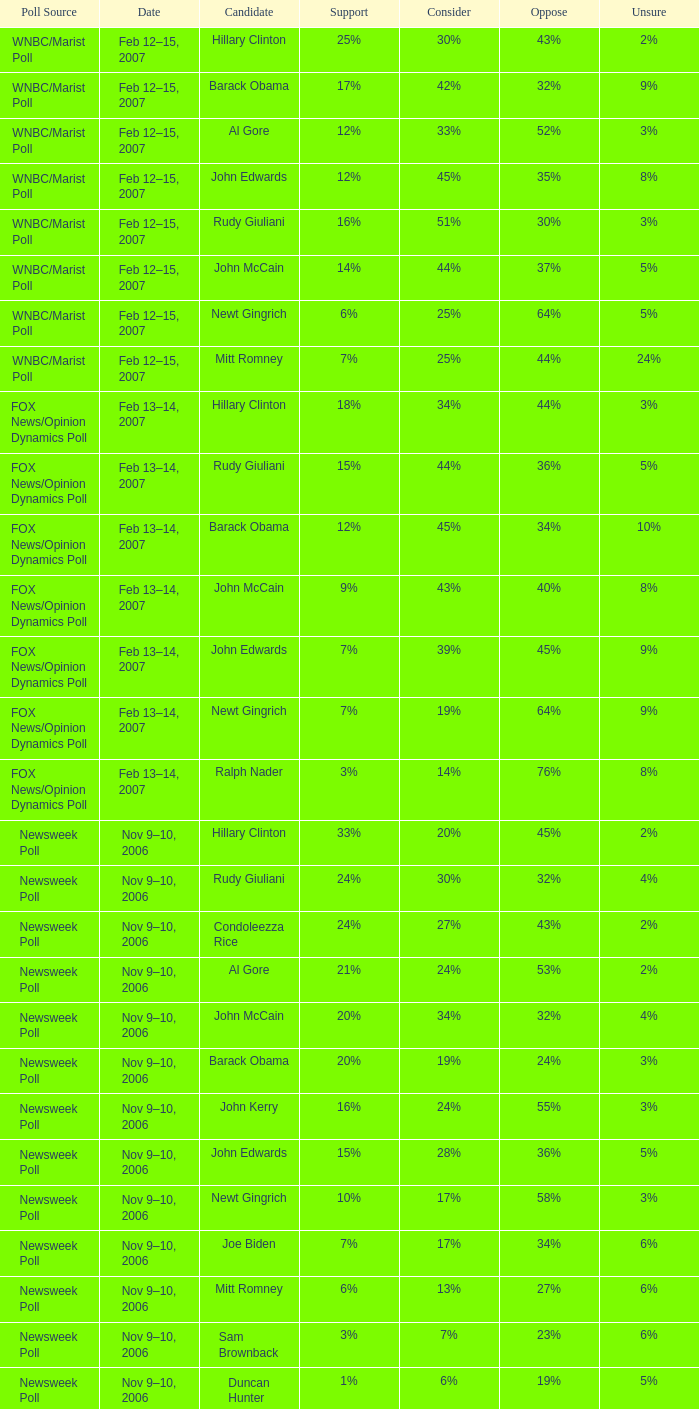In the time poll, which showed 6% of people being unsure, what was the percentage of those who did not support the candidate? 34%. Parse the table in full. {'header': ['Poll Source', 'Date', 'Candidate', 'Support', 'Consider', 'Oppose', 'Unsure'], 'rows': [['WNBC/Marist Poll', 'Feb 12–15, 2007', 'Hillary Clinton', '25%', '30%', '43%', '2%'], ['WNBC/Marist Poll', 'Feb 12–15, 2007', 'Barack Obama', '17%', '42%', '32%', '9%'], ['WNBC/Marist Poll', 'Feb 12–15, 2007', 'Al Gore', '12%', '33%', '52%', '3%'], ['WNBC/Marist Poll', 'Feb 12–15, 2007', 'John Edwards', '12%', '45%', '35%', '8%'], ['WNBC/Marist Poll', 'Feb 12–15, 2007', 'Rudy Giuliani', '16%', '51%', '30%', '3%'], ['WNBC/Marist Poll', 'Feb 12–15, 2007', 'John McCain', '14%', '44%', '37%', '5%'], ['WNBC/Marist Poll', 'Feb 12–15, 2007', 'Newt Gingrich', '6%', '25%', '64%', '5%'], ['WNBC/Marist Poll', 'Feb 12–15, 2007', 'Mitt Romney', '7%', '25%', '44%', '24%'], ['FOX News/Opinion Dynamics Poll', 'Feb 13–14, 2007', 'Hillary Clinton', '18%', '34%', '44%', '3%'], ['FOX News/Opinion Dynamics Poll', 'Feb 13–14, 2007', 'Rudy Giuliani', '15%', '44%', '36%', '5%'], ['FOX News/Opinion Dynamics Poll', 'Feb 13–14, 2007', 'Barack Obama', '12%', '45%', '34%', '10%'], ['FOX News/Opinion Dynamics Poll', 'Feb 13–14, 2007', 'John McCain', '9%', '43%', '40%', '8%'], ['FOX News/Opinion Dynamics Poll', 'Feb 13–14, 2007', 'John Edwards', '7%', '39%', '45%', '9%'], ['FOX News/Opinion Dynamics Poll', 'Feb 13–14, 2007', 'Newt Gingrich', '7%', '19%', '64%', '9%'], ['FOX News/Opinion Dynamics Poll', 'Feb 13–14, 2007', 'Ralph Nader', '3%', '14%', '76%', '8%'], ['Newsweek Poll', 'Nov 9–10, 2006', 'Hillary Clinton', '33%', '20%', '45%', '2%'], ['Newsweek Poll', 'Nov 9–10, 2006', 'Rudy Giuliani', '24%', '30%', '32%', '4%'], ['Newsweek Poll', 'Nov 9–10, 2006', 'Condoleezza Rice', '24%', '27%', '43%', '2%'], ['Newsweek Poll', 'Nov 9–10, 2006', 'Al Gore', '21%', '24%', '53%', '2%'], ['Newsweek Poll', 'Nov 9–10, 2006', 'John McCain', '20%', '34%', '32%', '4%'], ['Newsweek Poll', 'Nov 9–10, 2006', 'Barack Obama', '20%', '19%', '24%', '3%'], ['Newsweek Poll', 'Nov 9–10, 2006', 'John Kerry', '16%', '24%', '55%', '3%'], ['Newsweek Poll', 'Nov 9–10, 2006', 'John Edwards', '15%', '28%', '36%', '5%'], ['Newsweek Poll', 'Nov 9–10, 2006', 'Newt Gingrich', '10%', '17%', '58%', '3%'], ['Newsweek Poll', 'Nov 9–10, 2006', 'Joe Biden', '7%', '17%', '34%', '6%'], ['Newsweek Poll', 'Nov 9–10, 2006', 'Mitt Romney', '6%', '13%', '27%', '6%'], ['Newsweek Poll', 'Nov 9–10, 2006', 'Sam Brownback', '3%', '7%', '23%', '6%'], ['Newsweek Poll', 'Nov 9–10, 2006', 'Duncan Hunter', '1%', '6%', '19%', '5%'], ['Time Poll', 'Oct 3–4, 2006', 'Rudy Giuliani', '17%', '55%', '19%', '18%'], ['Time Poll', 'Oct 3–4, 2006', 'Hillary Rodham Clinton', '23%', '36%', '37%', '5%'], ['Time Poll', 'Oct 3–4, 2006', 'John McCain', '12%', '56%', '19%', '13%'], ['Time Poll', 'Oct 3–4, 2006', 'Al Gore', '16%', '44%', '35%', '5%'], ['Time Poll', 'Oct 3–4, 2006', 'John Kerry', '14%', '43%', '34%', '9%'], ['Time Poll', 'Jul 13–17, 2006', 'Rudy Giuliani', '17%', '54%', '14%', '15%'], ['Time Poll', 'Jul 13–17, 2006', 'Hillary Rodham Clinton', '19%', '41%', '34%', '6%'], ['Time Poll', 'Jul 13–17, 2006', 'John McCain', '12%', '52%', '13%', '22%'], ['Time Poll', 'Jul 13–17, 2006', 'Al Gore', '16%', '45%', '32%', '7%'], ['Time Poll', 'Jul 13–17, 2006', 'John Kerry', '12%', '48%', '30%', '10%'], ['CNN Poll', 'Jun 1–6, 2006', 'Hillary Rodham Clinton', '22%', '28%', '47%', '3%'], ['CNN Poll', 'Jun 1–6, 2006', 'Al Gore', '17%', '32%', '48%', '3%'], ['CNN Poll', 'Jun 1–6, 2006', 'John Kerry', '14%', '35%', '47%', '4%'], ['CNN Poll', 'Jun 1–6, 2006', 'Rudolph Giuliani', '19%', '45%', '30%', '6%'], ['CNN Poll', 'Jun 1–6, 2006', 'John McCain', '12%', '48%', '34%', '6%'], ['CNN Poll', 'Jun 1–6, 2006', 'Jeb Bush', '9%', '26%', '63%', '2%'], ['ABC News/Washington Post Poll', 'May 11–15, 2006', 'Hillary Clinton', '19%', '38%', '42%', '1%'], ['ABC News/Washington Post Poll', 'May 11–15, 2006', 'John McCain', '9%', '57%', '28%', '6%'], ['FOX News/Opinion Dynamics Poll', 'Feb 7–8, 2006', 'Hillary Clinton', '35%', '19%', '44%', '2%'], ['FOX News/Opinion Dynamics Poll', 'Feb 7–8, 2006', 'Rudy Giuliani', '33%', '38%', '24%', '6%'], ['FOX News/Opinion Dynamics Poll', 'Feb 7–8, 2006', 'John McCain', '30%', '40%', '22%', '7%'], ['FOX News/Opinion Dynamics Poll', 'Feb 7–8, 2006', 'John Kerry', '29%', '23%', '45%', '3%'], ['FOX News/Opinion Dynamics Poll', 'Feb 7–8, 2006', 'Condoleezza Rice', '14%', '38%', '46%', '3%'], ['CNN/USA Today/Gallup Poll', 'Jan 20–22, 2006', 'Hillary Rodham Clinton', '16%', '32%', '51%', '1%'], ['Diageo/Hotline Poll', 'Nov 11–15, 2005', 'John McCain', '23%', '46%', '15%', '15%'], ['CNN/USA Today/Gallup Poll', 'May 20–22, 2005', 'Hillary Rodham Clinton', '28%', '31%', '40%', '1%'], ['CNN/USA Today/Gallup Poll', 'Jun 9–10, 2003', 'Hillary Rodham Clinton', '20%', '33%', '45%', '2%']]} 